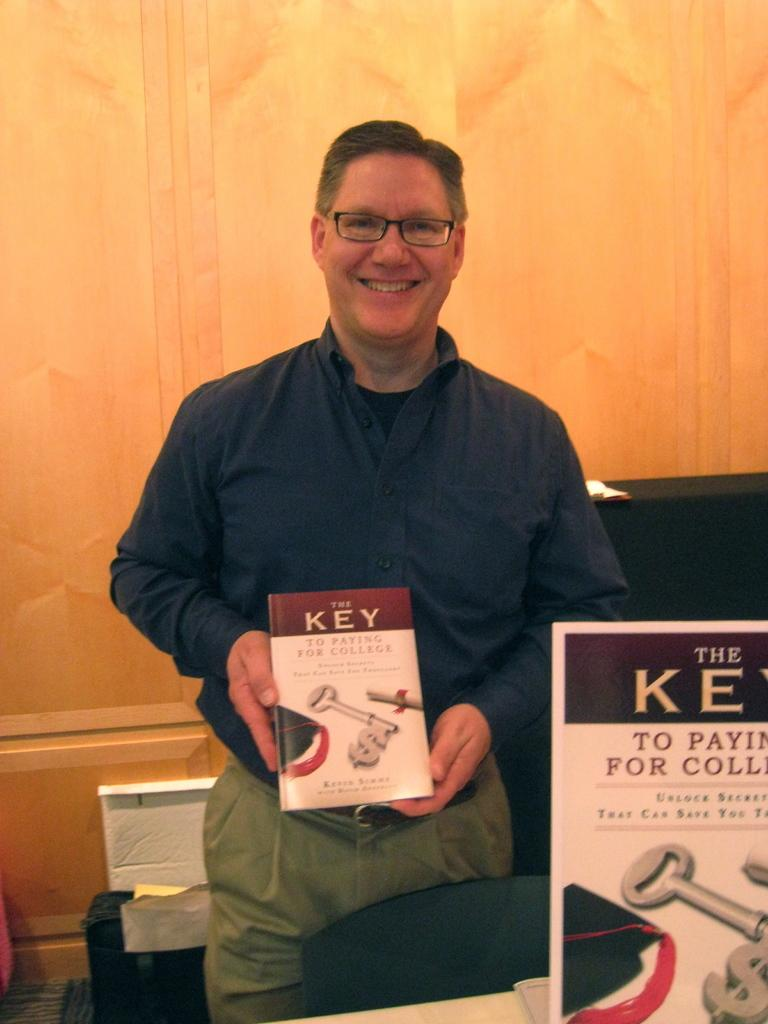<image>
Offer a succinct explanation of the picture presented. A man holding up a book titled "The Key To Paying For College." 